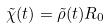<formula> <loc_0><loc_0><loc_500><loc_500>\tilde { \chi } ( t ) = \tilde { \rho } ( t ) R _ { 0 }</formula> 